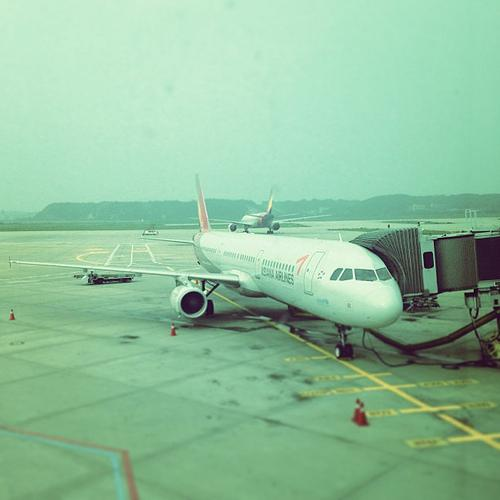Question: what is the color of the lettering on the plane?
Choices:
A. Red.
B. Black.
C. Blue.
D. White.
Answer with the letter. Answer: B Question: what kind of vehicle do you see?
Choices:
A. Boat.
B. Car.
C. Bus.
D. Aircraft.
Answer with the letter. Answer: D Question: who flies the plane?
Choices:
A. Flight attendant.
B. Passenger.
C. Pilot.
D. Student.
Answer with the letter. Answer: C 